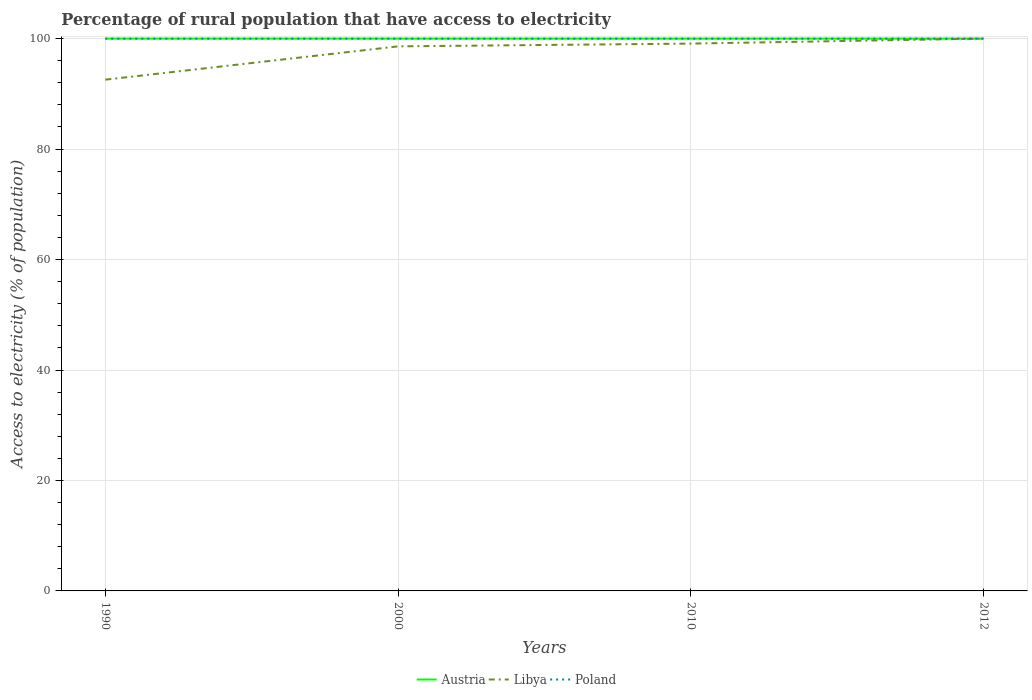Does the line corresponding to Libya intersect with the line corresponding to Austria?
Your response must be concise. Yes. Across all years, what is the maximum percentage of rural population that have access to electricity in Austria?
Make the answer very short. 100. In which year was the percentage of rural population that have access to electricity in Poland maximum?
Your response must be concise. 1990. What is the total percentage of rural population that have access to electricity in Poland in the graph?
Make the answer very short. 0. What is the difference between the highest and the lowest percentage of rural population that have access to electricity in Libya?
Your response must be concise. 3. How many years are there in the graph?
Offer a very short reply. 4. Does the graph contain grids?
Offer a terse response. Yes. Where does the legend appear in the graph?
Your answer should be very brief. Bottom center. How are the legend labels stacked?
Your answer should be very brief. Horizontal. What is the title of the graph?
Keep it short and to the point. Percentage of rural population that have access to electricity. What is the label or title of the X-axis?
Provide a short and direct response. Years. What is the label or title of the Y-axis?
Your answer should be compact. Access to electricity (% of population). What is the Access to electricity (% of population) of Austria in 1990?
Your answer should be compact. 100. What is the Access to electricity (% of population) of Libya in 1990?
Your answer should be very brief. 92.57. What is the Access to electricity (% of population) in Libya in 2000?
Your response must be concise. 98.6. What is the Access to electricity (% of population) in Austria in 2010?
Offer a terse response. 100. What is the Access to electricity (% of population) in Libya in 2010?
Make the answer very short. 99.1. What is the Access to electricity (% of population) of Poland in 2010?
Give a very brief answer. 100. What is the Access to electricity (% of population) of Poland in 2012?
Your response must be concise. 100. Across all years, what is the maximum Access to electricity (% of population) in Austria?
Keep it short and to the point. 100. Across all years, what is the maximum Access to electricity (% of population) of Poland?
Ensure brevity in your answer.  100. Across all years, what is the minimum Access to electricity (% of population) in Austria?
Your response must be concise. 100. Across all years, what is the minimum Access to electricity (% of population) in Libya?
Provide a succinct answer. 92.57. What is the total Access to electricity (% of population) in Libya in the graph?
Provide a short and direct response. 390.27. What is the difference between the Access to electricity (% of population) of Libya in 1990 and that in 2000?
Provide a succinct answer. -6.03. What is the difference between the Access to electricity (% of population) in Poland in 1990 and that in 2000?
Provide a short and direct response. 0. What is the difference between the Access to electricity (% of population) of Libya in 1990 and that in 2010?
Make the answer very short. -6.53. What is the difference between the Access to electricity (% of population) in Poland in 1990 and that in 2010?
Provide a succinct answer. 0. What is the difference between the Access to electricity (% of population) in Austria in 1990 and that in 2012?
Make the answer very short. 0. What is the difference between the Access to electricity (% of population) in Libya in 1990 and that in 2012?
Your response must be concise. -7.43. What is the difference between the Access to electricity (% of population) in Poland in 1990 and that in 2012?
Your response must be concise. 0. What is the difference between the Access to electricity (% of population) in Libya in 2000 and that in 2010?
Make the answer very short. -0.5. What is the difference between the Access to electricity (% of population) of Poland in 2000 and that in 2010?
Your answer should be very brief. 0. What is the difference between the Access to electricity (% of population) in Austria in 2000 and that in 2012?
Provide a succinct answer. 0. What is the difference between the Access to electricity (% of population) in Poland in 2000 and that in 2012?
Provide a short and direct response. 0. What is the difference between the Access to electricity (% of population) of Austria in 2010 and that in 2012?
Offer a terse response. 0. What is the difference between the Access to electricity (% of population) of Libya in 2010 and that in 2012?
Make the answer very short. -0.9. What is the difference between the Access to electricity (% of population) of Austria in 1990 and the Access to electricity (% of population) of Poland in 2000?
Make the answer very short. 0. What is the difference between the Access to electricity (% of population) of Libya in 1990 and the Access to electricity (% of population) of Poland in 2000?
Ensure brevity in your answer.  -7.43. What is the difference between the Access to electricity (% of population) in Libya in 1990 and the Access to electricity (% of population) in Poland in 2010?
Give a very brief answer. -7.43. What is the difference between the Access to electricity (% of population) of Austria in 1990 and the Access to electricity (% of population) of Libya in 2012?
Your answer should be compact. 0. What is the difference between the Access to electricity (% of population) in Austria in 1990 and the Access to electricity (% of population) in Poland in 2012?
Your answer should be very brief. 0. What is the difference between the Access to electricity (% of population) of Libya in 1990 and the Access to electricity (% of population) of Poland in 2012?
Offer a very short reply. -7.43. What is the difference between the Access to electricity (% of population) of Austria in 2000 and the Access to electricity (% of population) of Libya in 2010?
Offer a very short reply. 0.9. What is the difference between the Access to electricity (% of population) of Austria in 2000 and the Access to electricity (% of population) of Poland in 2010?
Ensure brevity in your answer.  0. What is the difference between the Access to electricity (% of population) of Austria in 2000 and the Access to electricity (% of population) of Poland in 2012?
Offer a very short reply. 0. What is the difference between the Access to electricity (% of population) of Libya in 2000 and the Access to electricity (% of population) of Poland in 2012?
Provide a succinct answer. -1.4. What is the difference between the Access to electricity (% of population) of Austria in 2010 and the Access to electricity (% of population) of Libya in 2012?
Offer a terse response. 0. What is the average Access to electricity (% of population) in Libya per year?
Offer a terse response. 97.57. What is the average Access to electricity (% of population) of Poland per year?
Provide a short and direct response. 100. In the year 1990, what is the difference between the Access to electricity (% of population) in Austria and Access to electricity (% of population) in Libya?
Provide a short and direct response. 7.43. In the year 1990, what is the difference between the Access to electricity (% of population) of Austria and Access to electricity (% of population) of Poland?
Your answer should be very brief. 0. In the year 1990, what is the difference between the Access to electricity (% of population) in Libya and Access to electricity (% of population) in Poland?
Make the answer very short. -7.43. In the year 2000, what is the difference between the Access to electricity (% of population) of Austria and Access to electricity (% of population) of Poland?
Give a very brief answer. 0. In the year 2010, what is the difference between the Access to electricity (% of population) of Libya and Access to electricity (% of population) of Poland?
Your answer should be compact. -0.9. In the year 2012, what is the difference between the Access to electricity (% of population) in Austria and Access to electricity (% of population) in Libya?
Make the answer very short. 0. In the year 2012, what is the difference between the Access to electricity (% of population) in Austria and Access to electricity (% of population) in Poland?
Offer a terse response. 0. In the year 2012, what is the difference between the Access to electricity (% of population) of Libya and Access to electricity (% of population) of Poland?
Offer a terse response. 0. What is the ratio of the Access to electricity (% of population) of Austria in 1990 to that in 2000?
Ensure brevity in your answer.  1. What is the ratio of the Access to electricity (% of population) of Libya in 1990 to that in 2000?
Provide a succinct answer. 0.94. What is the ratio of the Access to electricity (% of population) of Libya in 1990 to that in 2010?
Give a very brief answer. 0.93. What is the ratio of the Access to electricity (% of population) of Poland in 1990 to that in 2010?
Keep it short and to the point. 1. What is the ratio of the Access to electricity (% of population) of Libya in 1990 to that in 2012?
Your answer should be compact. 0.93. What is the ratio of the Access to electricity (% of population) of Libya in 2000 to that in 2010?
Provide a short and direct response. 0.99. What is the ratio of the Access to electricity (% of population) in Austria in 2000 to that in 2012?
Ensure brevity in your answer.  1. What is the ratio of the Access to electricity (% of population) of Poland in 2000 to that in 2012?
Keep it short and to the point. 1. What is the ratio of the Access to electricity (% of population) in Libya in 2010 to that in 2012?
Make the answer very short. 0.99. What is the difference between the highest and the second highest Access to electricity (% of population) of Libya?
Your answer should be compact. 0.9. What is the difference between the highest and the lowest Access to electricity (% of population) of Libya?
Offer a very short reply. 7.43. 